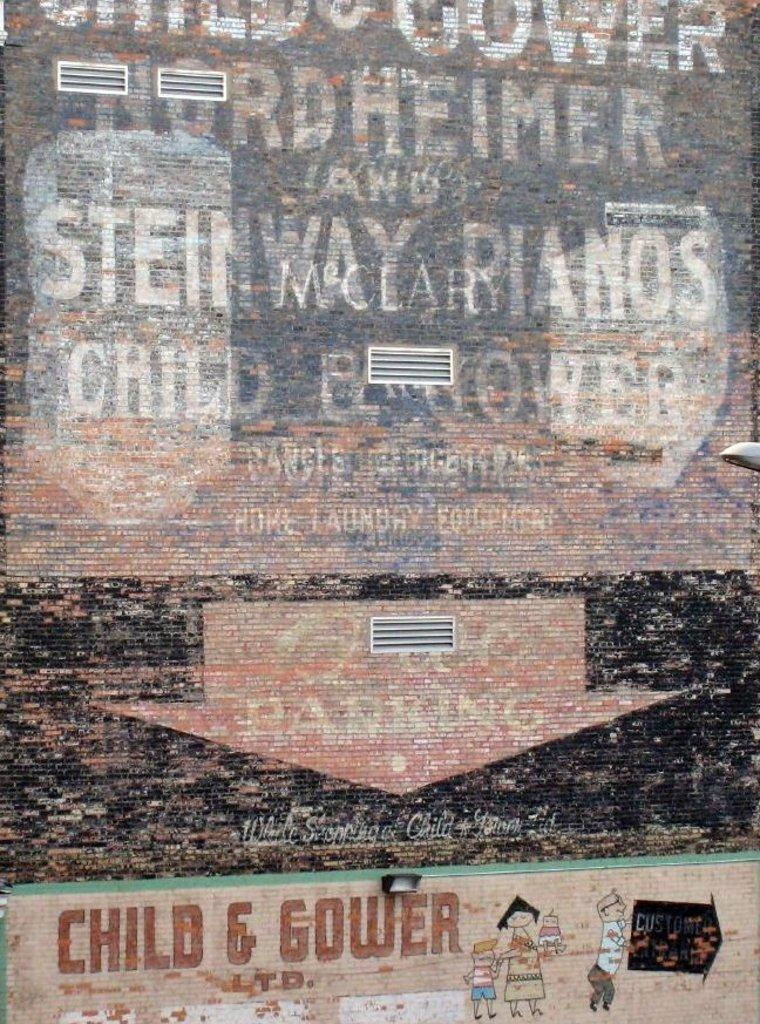<image>
Share a concise interpretation of the image provided. Several layers of advertisements bleed through one another on a wall, including a Piano company. 